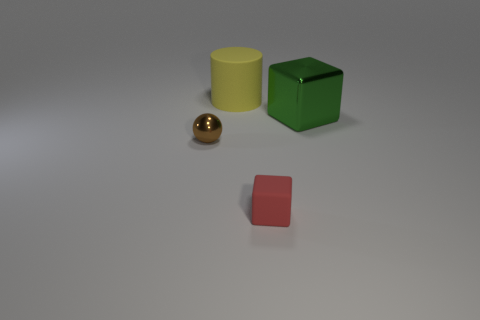Add 2 large cyan balls. How many objects exist? 6 Subtract all spheres. How many objects are left? 3 Subtract all yellow objects. Subtract all large cyan metal cylinders. How many objects are left? 3 Add 1 matte cylinders. How many matte cylinders are left? 2 Add 2 big green objects. How many big green objects exist? 3 Subtract 0 red cylinders. How many objects are left? 4 